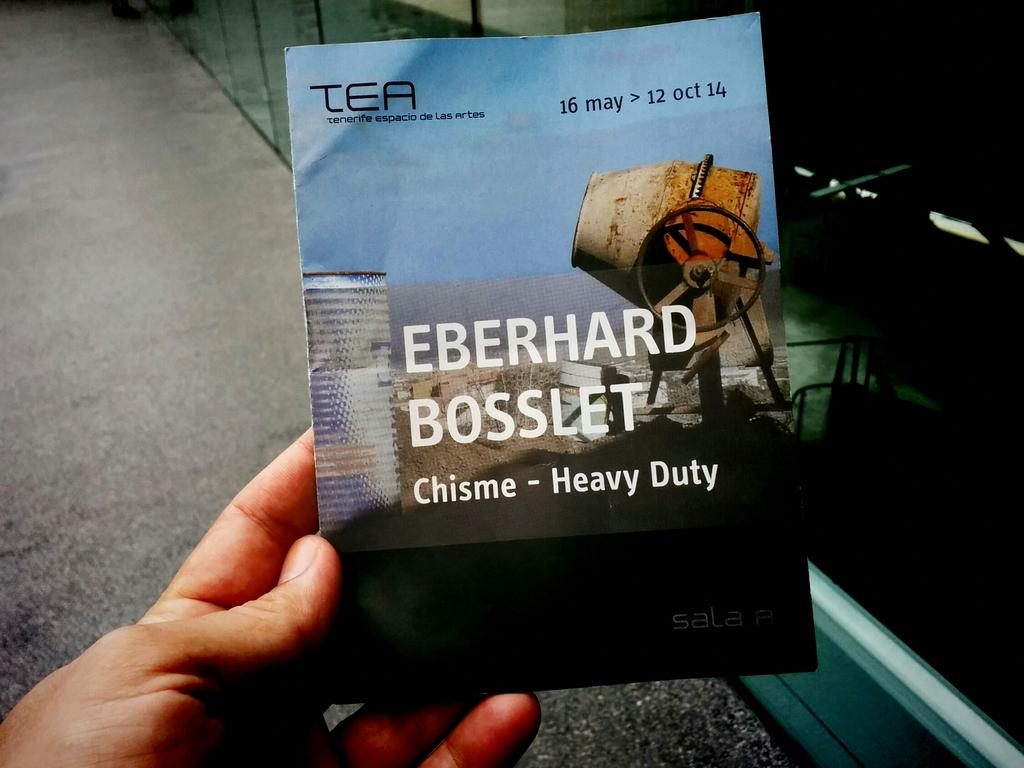<image>
Share a concise interpretation of the image provided. Person holding a booklet which says "EBERHARD BOSSLET" on it. 